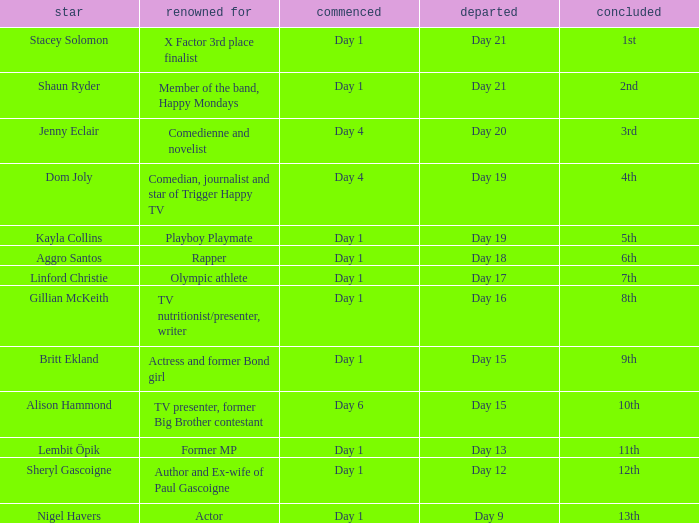What position did the celebrity finish that entered on day 1 and exited on day 15? 9th. 